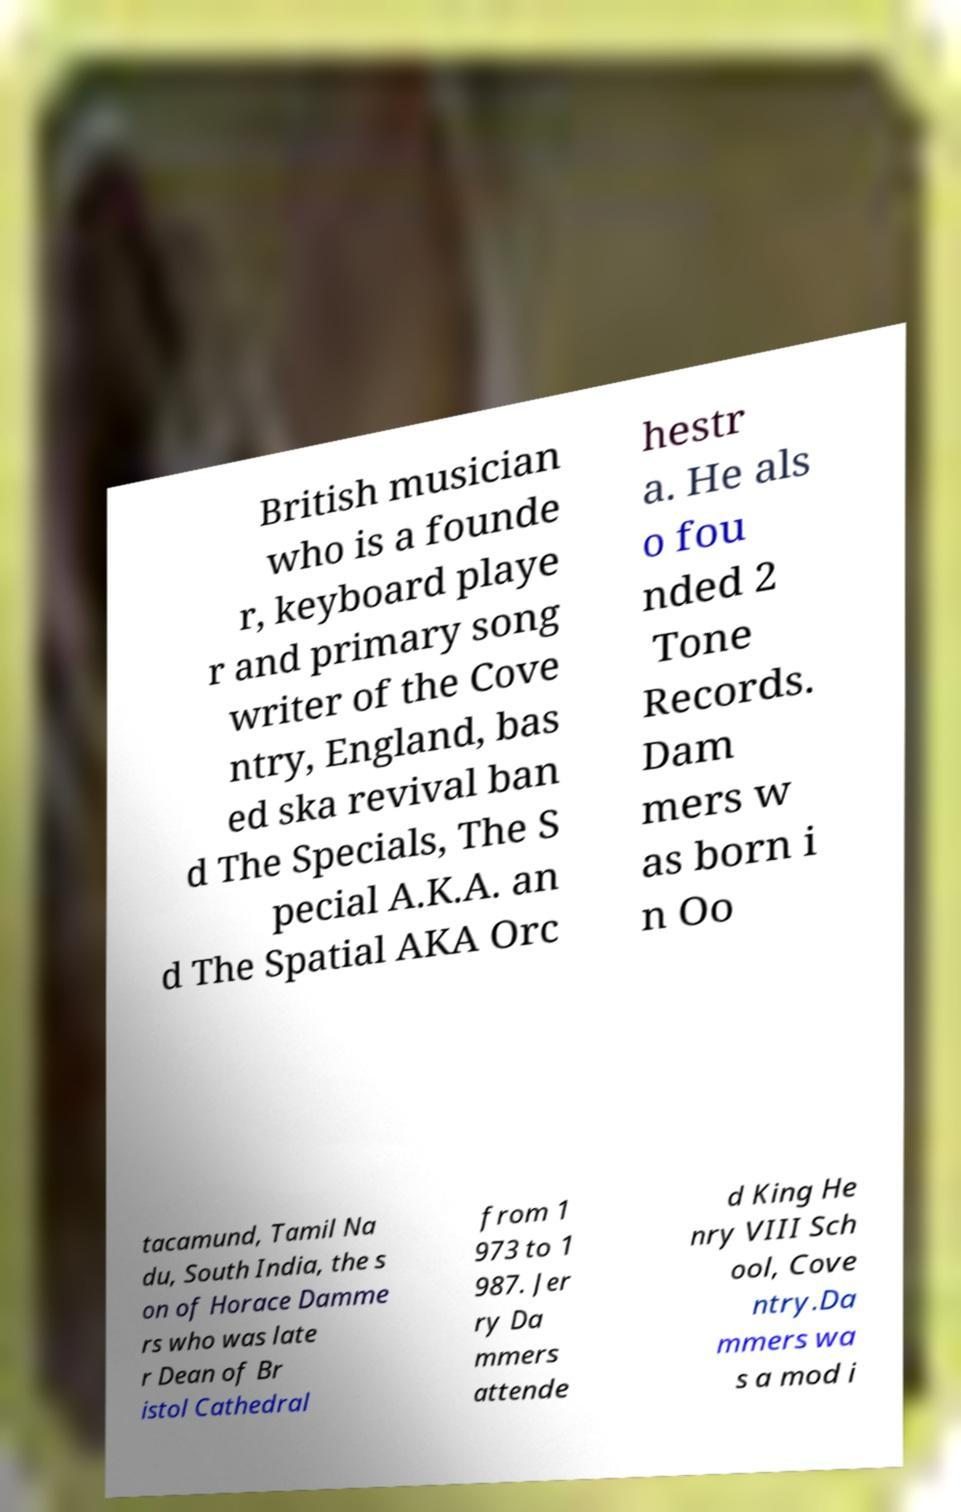For documentation purposes, I need the text within this image transcribed. Could you provide that? British musician who is a founde r, keyboard playe r and primary song writer of the Cove ntry, England, bas ed ska revival ban d The Specials, The S pecial A.K.A. an d The Spatial AKA Orc hestr a. He als o fou nded 2 Tone Records. Dam mers w as born i n Oo tacamund, Tamil Na du, South India, the s on of Horace Damme rs who was late r Dean of Br istol Cathedral from 1 973 to 1 987. Jer ry Da mmers attende d King He nry VIII Sch ool, Cove ntry.Da mmers wa s a mod i 